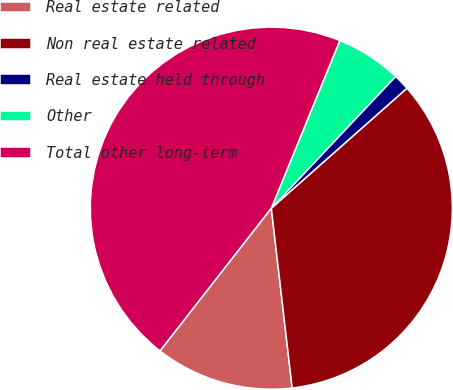Convert chart. <chart><loc_0><loc_0><loc_500><loc_500><pie_chart><fcel>Real estate related<fcel>Non real estate related<fcel>Real estate held through<fcel>Other<fcel>Total other long-term<nl><fcel>12.38%<fcel>34.69%<fcel>1.44%<fcel>5.86%<fcel>45.63%<nl></chart> 